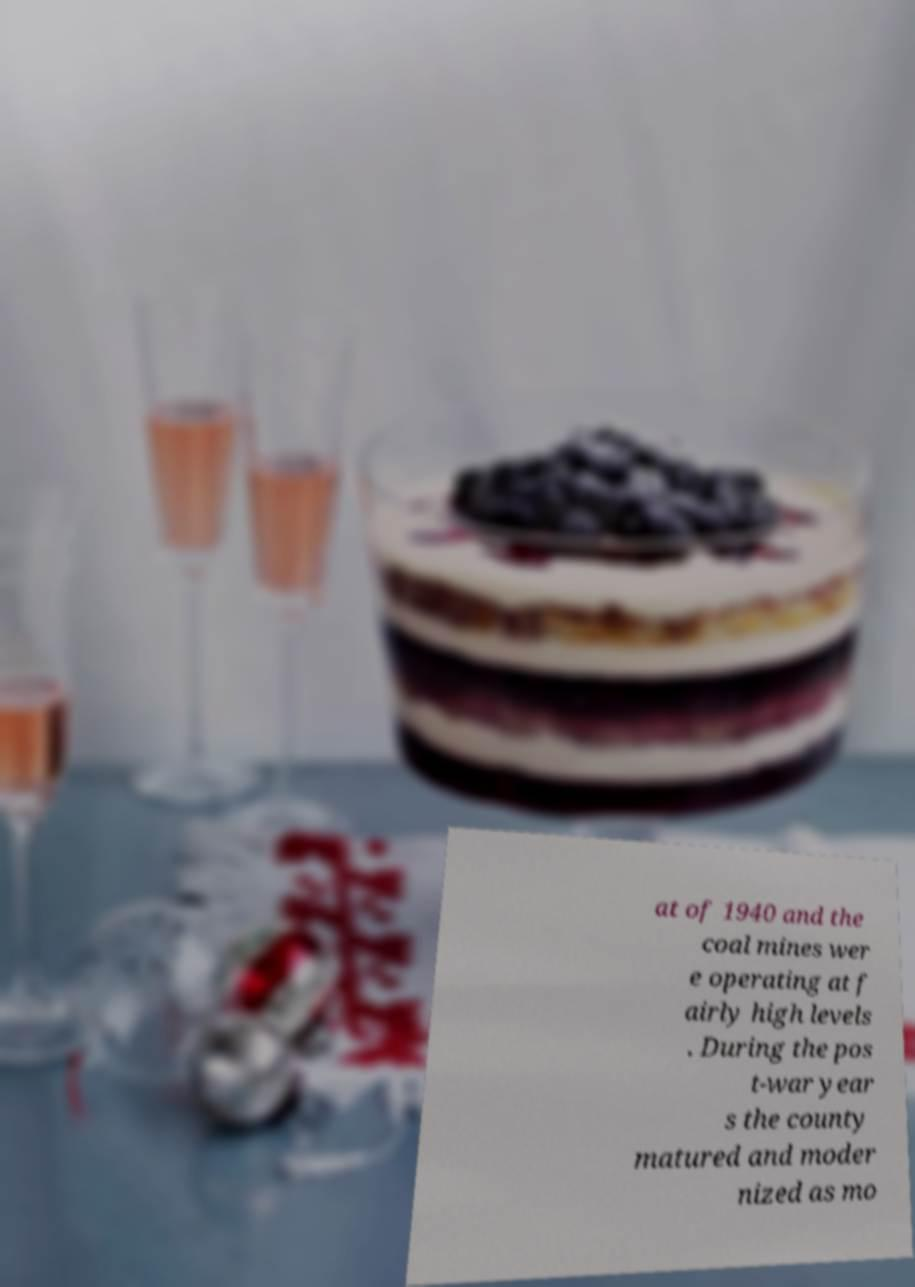Can you read and provide the text displayed in the image?This photo seems to have some interesting text. Can you extract and type it out for me? at of 1940 and the coal mines wer e operating at f airly high levels . During the pos t-war year s the county matured and moder nized as mo 